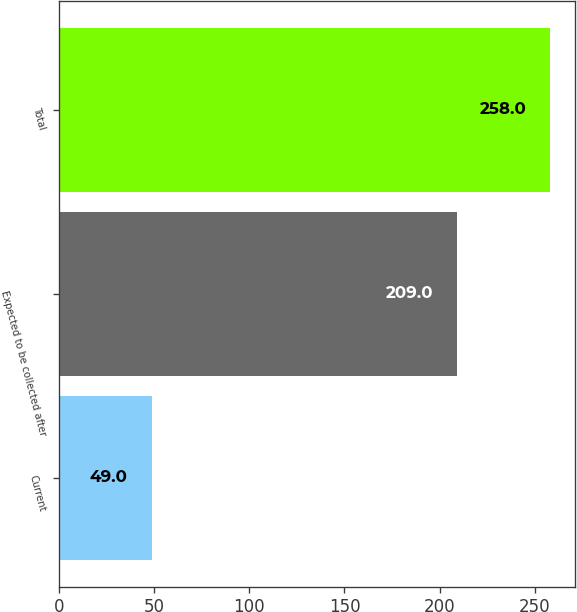<chart> <loc_0><loc_0><loc_500><loc_500><bar_chart><fcel>Current<fcel>Expected to be collected after<fcel>Total<nl><fcel>49<fcel>209<fcel>258<nl></chart> 